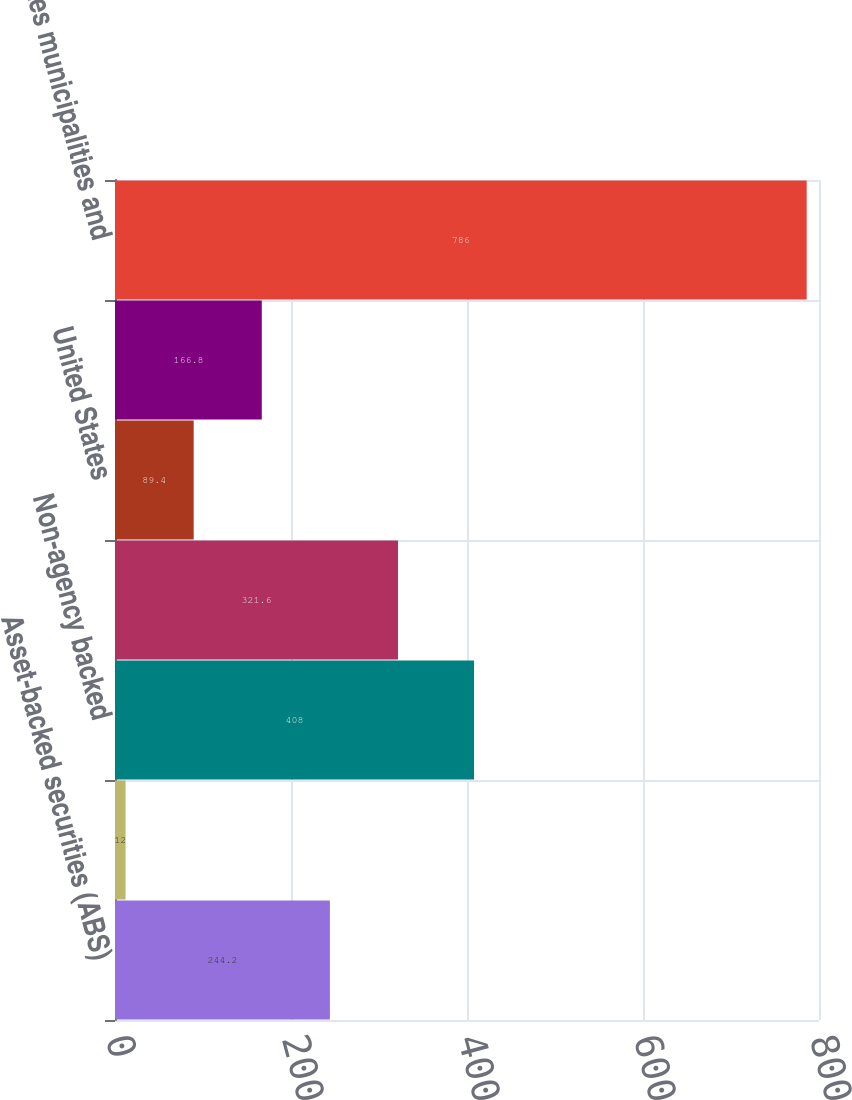Convert chart to OTSL. <chart><loc_0><loc_0><loc_500><loc_500><bar_chart><fcel>Asset-backed securities (ABS)<fcel>Agency backed<fcel>Non-agency backed<fcel>Foreign<fcel>United States<fcel>US Government/Government<fcel>States municipalities and<nl><fcel>244.2<fcel>12<fcel>408<fcel>321.6<fcel>89.4<fcel>166.8<fcel>786<nl></chart> 